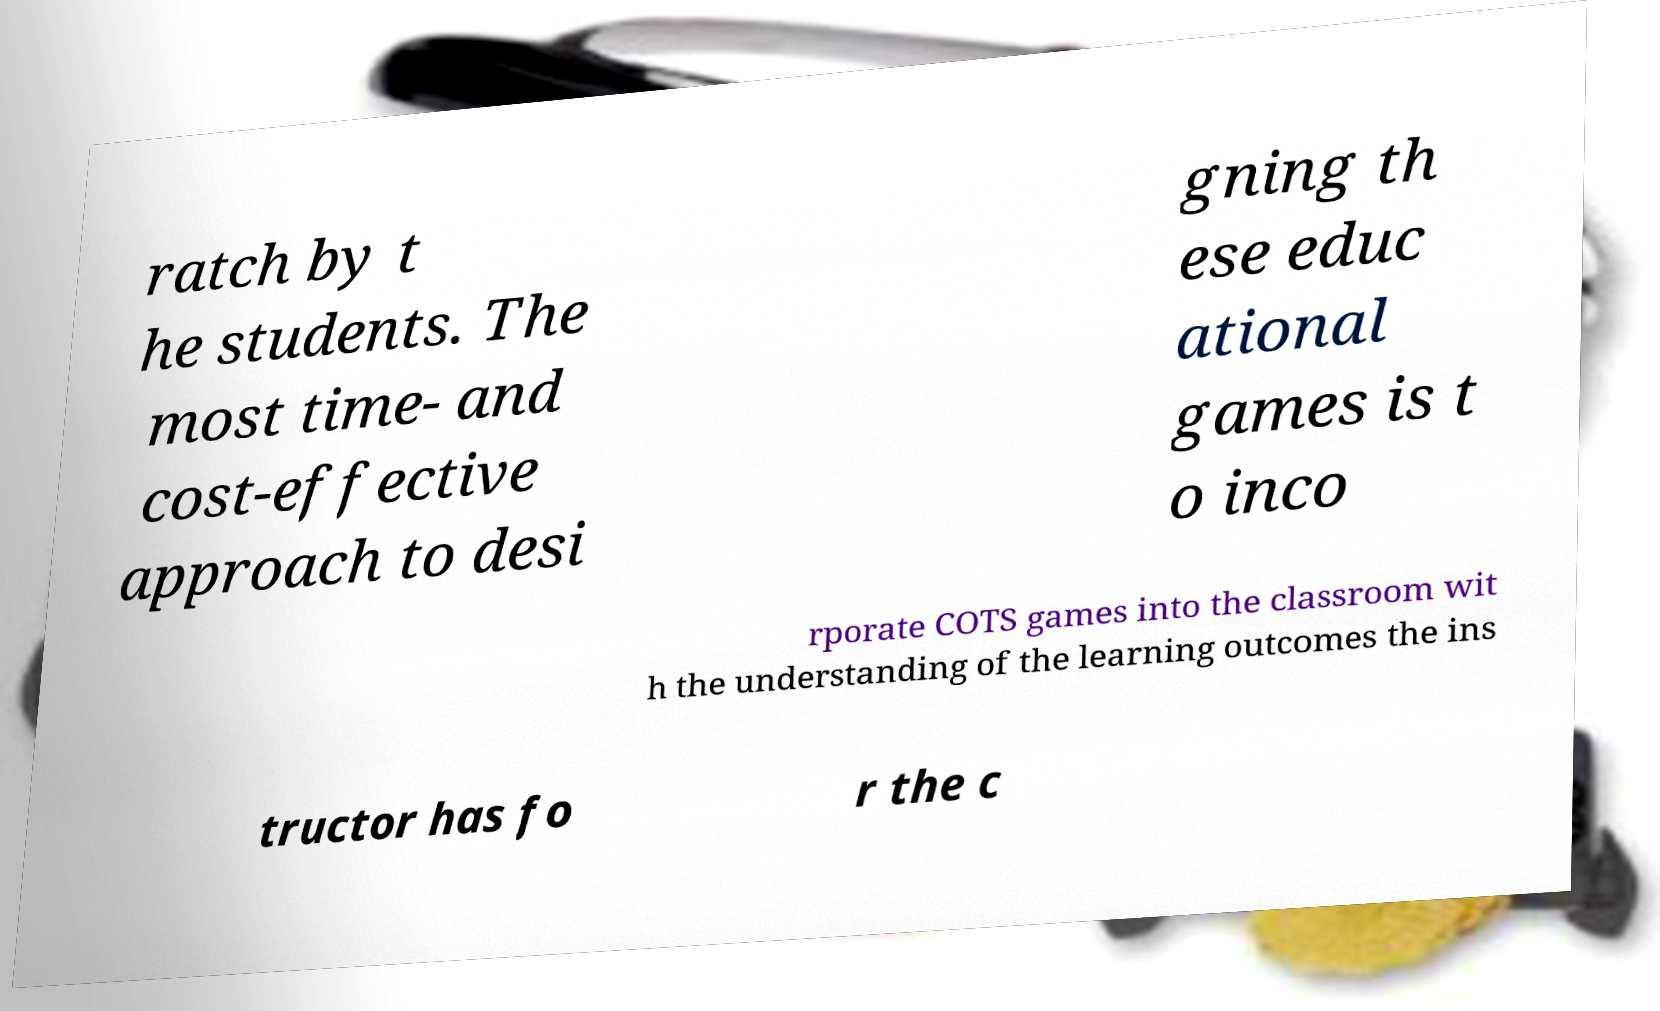Please identify and transcribe the text found in this image. ratch by t he students. The most time- and cost-effective approach to desi gning th ese educ ational games is t o inco rporate COTS games into the classroom wit h the understanding of the learning outcomes the ins tructor has fo r the c 